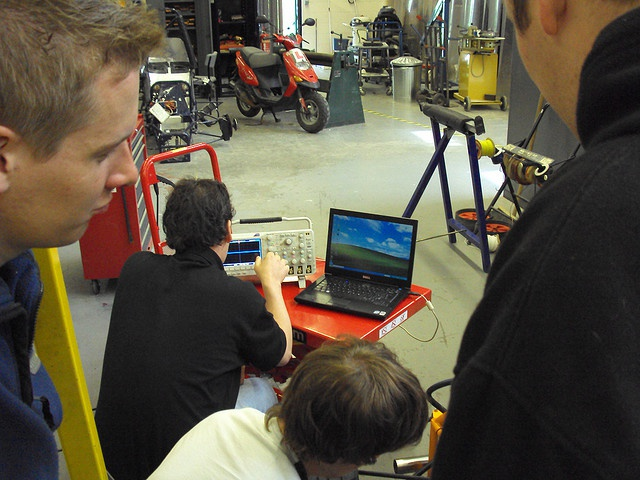Describe the objects in this image and their specific colors. I can see people in black, olive, brown, and maroon tones, people in black and gray tones, people in black, khaki, gray, and tan tones, people in black, beige, and gray tones, and laptop in black, blue, gray, and darkgreen tones in this image. 